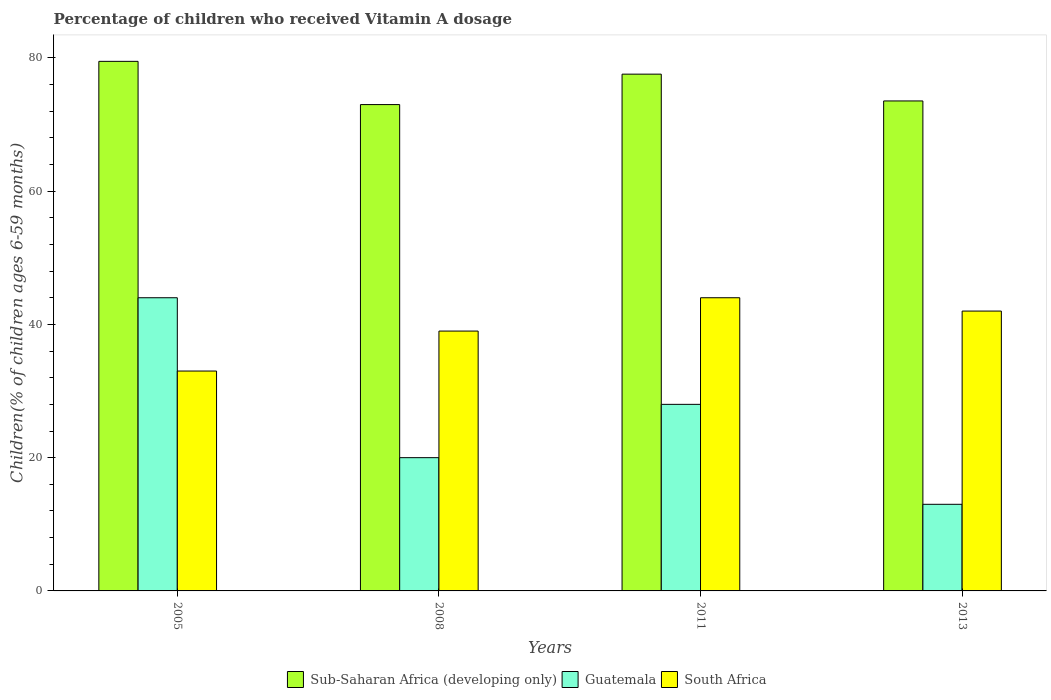How many groups of bars are there?
Your answer should be compact. 4. Are the number of bars per tick equal to the number of legend labels?
Provide a short and direct response. Yes. What is the label of the 4th group of bars from the left?
Offer a very short reply. 2013. In how many cases, is the number of bars for a given year not equal to the number of legend labels?
Offer a very short reply. 0. Across all years, what is the minimum percentage of children who received Vitamin A dosage in Guatemala?
Your response must be concise. 13. In which year was the percentage of children who received Vitamin A dosage in Guatemala minimum?
Ensure brevity in your answer.  2013. What is the total percentage of children who received Vitamin A dosage in Sub-Saharan Africa (developing only) in the graph?
Offer a terse response. 303.56. What is the difference between the percentage of children who received Vitamin A dosage in Sub-Saharan Africa (developing only) in 2008 and the percentage of children who received Vitamin A dosage in Guatemala in 2011?
Make the answer very short. 44.99. What is the average percentage of children who received Vitamin A dosage in Sub-Saharan Africa (developing only) per year?
Your response must be concise. 75.89. In the year 2008, what is the difference between the percentage of children who received Vitamin A dosage in South Africa and percentage of children who received Vitamin A dosage in Sub-Saharan Africa (developing only)?
Provide a short and direct response. -33.99. In how many years, is the percentage of children who received Vitamin A dosage in South Africa greater than 44 %?
Your response must be concise. 0. What is the ratio of the percentage of children who received Vitamin A dosage in Sub-Saharan Africa (developing only) in 2005 to that in 2011?
Keep it short and to the point. 1.02. Is the percentage of children who received Vitamin A dosage in Sub-Saharan Africa (developing only) in 2008 less than that in 2011?
Your answer should be compact. Yes. What is the difference between the highest and the second highest percentage of children who received Vitamin A dosage in Sub-Saharan Africa (developing only)?
Give a very brief answer. 1.92. What is the difference between the highest and the lowest percentage of children who received Vitamin A dosage in Sub-Saharan Africa (developing only)?
Ensure brevity in your answer.  6.49. What does the 2nd bar from the left in 2005 represents?
Offer a terse response. Guatemala. What does the 2nd bar from the right in 2005 represents?
Offer a terse response. Guatemala. Does the graph contain grids?
Give a very brief answer. No. How many legend labels are there?
Ensure brevity in your answer.  3. What is the title of the graph?
Ensure brevity in your answer.  Percentage of children who received Vitamin A dosage. Does "Mauritius" appear as one of the legend labels in the graph?
Offer a very short reply. No. What is the label or title of the X-axis?
Your answer should be very brief. Years. What is the label or title of the Y-axis?
Your response must be concise. Children(% of children ages 6-59 months). What is the Children(% of children ages 6-59 months) of Sub-Saharan Africa (developing only) in 2005?
Offer a very short reply. 79.48. What is the Children(% of children ages 6-59 months) of Guatemala in 2005?
Provide a succinct answer. 44. What is the Children(% of children ages 6-59 months) in South Africa in 2005?
Offer a terse response. 33. What is the Children(% of children ages 6-59 months) in Sub-Saharan Africa (developing only) in 2008?
Provide a succinct answer. 72.99. What is the Children(% of children ages 6-59 months) in Guatemala in 2008?
Provide a succinct answer. 20. What is the Children(% of children ages 6-59 months) of Sub-Saharan Africa (developing only) in 2011?
Make the answer very short. 77.56. What is the Children(% of children ages 6-59 months) in Guatemala in 2011?
Your answer should be very brief. 28. What is the Children(% of children ages 6-59 months) of Sub-Saharan Africa (developing only) in 2013?
Your answer should be very brief. 73.54. What is the Children(% of children ages 6-59 months) in Guatemala in 2013?
Your answer should be compact. 13. What is the Children(% of children ages 6-59 months) in South Africa in 2013?
Your response must be concise. 42. Across all years, what is the maximum Children(% of children ages 6-59 months) in Sub-Saharan Africa (developing only)?
Keep it short and to the point. 79.48. Across all years, what is the maximum Children(% of children ages 6-59 months) in Guatemala?
Provide a succinct answer. 44. Across all years, what is the maximum Children(% of children ages 6-59 months) of South Africa?
Offer a terse response. 44. Across all years, what is the minimum Children(% of children ages 6-59 months) of Sub-Saharan Africa (developing only)?
Make the answer very short. 72.99. Across all years, what is the minimum Children(% of children ages 6-59 months) of South Africa?
Your answer should be compact. 33. What is the total Children(% of children ages 6-59 months) of Sub-Saharan Africa (developing only) in the graph?
Keep it short and to the point. 303.56. What is the total Children(% of children ages 6-59 months) in Guatemala in the graph?
Your response must be concise. 105. What is the total Children(% of children ages 6-59 months) of South Africa in the graph?
Your answer should be compact. 158. What is the difference between the Children(% of children ages 6-59 months) in Sub-Saharan Africa (developing only) in 2005 and that in 2008?
Offer a terse response. 6.49. What is the difference between the Children(% of children ages 6-59 months) in South Africa in 2005 and that in 2008?
Offer a terse response. -6. What is the difference between the Children(% of children ages 6-59 months) of Sub-Saharan Africa (developing only) in 2005 and that in 2011?
Keep it short and to the point. 1.92. What is the difference between the Children(% of children ages 6-59 months) of Sub-Saharan Africa (developing only) in 2005 and that in 2013?
Your answer should be compact. 5.94. What is the difference between the Children(% of children ages 6-59 months) in South Africa in 2005 and that in 2013?
Give a very brief answer. -9. What is the difference between the Children(% of children ages 6-59 months) of Sub-Saharan Africa (developing only) in 2008 and that in 2011?
Ensure brevity in your answer.  -4.57. What is the difference between the Children(% of children ages 6-59 months) of Guatemala in 2008 and that in 2011?
Provide a short and direct response. -8. What is the difference between the Children(% of children ages 6-59 months) of Sub-Saharan Africa (developing only) in 2008 and that in 2013?
Give a very brief answer. -0.55. What is the difference between the Children(% of children ages 6-59 months) in Sub-Saharan Africa (developing only) in 2011 and that in 2013?
Make the answer very short. 4.02. What is the difference between the Children(% of children ages 6-59 months) in Sub-Saharan Africa (developing only) in 2005 and the Children(% of children ages 6-59 months) in Guatemala in 2008?
Provide a succinct answer. 59.48. What is the difference between the Children(% of children ages 6-59 months) of Sub-Saharan Africa (developing only) in 2005 and the Children(% of children ages 6-59 months) of South Africa in 2008?
Provide a short and direct response. 40.48. What is the difference between the Children(% of children ages 6-59 months) in Guatemala in 2005 and the Children(% of children ages 6-59 months) in South Africa in 2008?
Your response must be concise. 5. What is the difference between the Children(% of children ages 6-59 months) in Sub-Saharan Africa (developing only) in 2005 and the Children(% of children ages 6-59 months) in Guatemala in 2011?
Your response must be concise. 51.48. What is the difference between the Children(% of children ages 6-59 months) of Sub-Saharan Africa (developing only) in 2005 and the Children(% of children ages 6-59 months) of South Africa in 2011?
Your answer should be compact. 35.48. What is the difference between the Children(% of children ages 6-59 months) of Sub-Saharan Africa (developing only) in 2005 and the Children(% of children ages 6-59 months) of Guatemala in 2013?
Provide a short and direct response. 66.48. What is the difference between the Children(% of children ages 6-59 months) in Sub-Saharan Africa (developing only) in 2005 and the Children(% of children ages 6-59 months) in South Africa in 2013?
Your answer should be very brief. 37.48. What is the difference between the Children(% of children ages 6-59 months) of Guatemala in 2005 and the Children(% of children ages 6-59 months) of South Africa in 2013?
Offer a terse response. 2. What is the difference between the Children(% of children ages 6-59 months) in Sub-Saharan Africa (developing only) in 2008 and the Children(% of children ages 6-59 months) in Guatemala in 2011?
Your answer should be compact. 44.99. What is the difference between the Children(% of children ages 6-59 months) of Sub-Saharan Africa (developing only) in 2008 and the Children(% of children ages 6-59 months) of South Africa in 2011?
Provide a succinct answer. 28.99. What is the difference between the Children(% of children ages 6-59 months) of Guatemala in 2008 and the Children(% of children ages 6-59 months) of South Africa in 2011?
Your answer should be compact. -24. What is the difference between the Children(% of children ages 6-59 months) in Sub-Saharan Africa (developing only) in 2008 and the Children(% of children ages 6-59 months) in Guatemala in 2013?
Your answer should be very brief. 59.99. What is the difference between the Children(% of children ages 6-59 months) of Sub-Saharan Africa (developing only) in 2008 and the Children(% of children ages 6-59 months) of South Africa in 2013?
Offer a terse response. 30.99. What is the difference between the Children(% of children ages 6-59 months) in Guatemala in 2008 and the Children(% of children ages 6-59 months) in South Africa in 2013?
Offer a terse response. -22. What is the difference between the Children(% of children ages 6-59 months) of Sub-Saharan Africa (developing only) in 2011 and the Children(% of children ages 6-59 months) of Guatemala in 2013?
Ensure brevity in your answer.  64.56. What is the difference between the Children(% of children ages 6-59 months) of Sub-Saharan Africa (developing only) in 2011 and the Children(% of children ages 6-59 months) of South Africa in 2013?
Provide a succinct answer. 35.56. What is the average Children(% of children ages 6-59 months) in Sub-Saharan Africa (developing only) per year?
Your response must be concise. 75.89. What is the average Children(% of children ages 6-59 months) of Guatemala per year?
Offer a terse response. 26.25. What is the average Children(% of children ages 6-59 months) in South Africa per year?
Offer a very short reply. 39.5. In the year 2005, what is the difference between the Children(% of children ages 6-59 months) of Sub-Saharan Africa (developing only) and Children(% of children ages 6-59 months) of Guatemala?
Provide a succinct answer. 35.48. In the year 2005, what is the difference between the Children(% of children ages 6-59 months) of Sub-Saharan Africa (developing only) and Children(% of children ages 6-59 months) of South Africa?
Make the answer very short. 46.48. In the year 2005, what is the difference between the Children(% of children ages 6-59 months) of Guatemala and Children(% of children ages 6-59 months) of South Africa?
Your answer should be compact. 11. In the year 2008, what is the difference between the Children(% of children ages 6-59 months) in Sub-Saharan Africa (developing only) and Children(% of children ages 6-59 months) in Guatemala?
Keep it short and to the point. 52.99. In the year 2008, what is the difference between the Children(% of children ages 6-59 months) in Sub-Saharan Africa (developing only) and Children(% of children ages 6-59 months) in South Africa?
Ensure brevity in your answer.  33.99. In the year 2011, what is the difference between the Children(% of children ages 6-59 months) of Sub-Saharan Africa (developing only) and Children(% of children ages 6-59 months) of Guatemala?
Your response must be concise. 49.56. In the year 2011, what is the difference between the Children(% of children ages 6-59 months) in Sub-Saharan Africa (developing only) and Children(% of children ages 6-59 months) in South Africa?
Provide a succinct answer. 33.56. In the year 2011, what is the difference between the Children(% of children ages 6-59 months) of Guatemala and Children(% of children ages 6-59 months) of South Africa?
Provide a succinct answer. -16. In the year 2013, what is the difference between the Children(% of children ages 6-59 months) in Sub-Saharan Africa (developing only) and Children(% of children ages 6-59 months) in Guatemala?
Provide a succinct answer. 60.54. In the year 2013, what is the difference between the Children(% of children ages 6-59 months) of Sub-Saharan Africa (developing only) and Children(% of children ages 6-59 months) of South Africa?
Provide a short and direct response. 31.54. What is the ratio of the Children(% of children ages 6-59 months) of Sub-Saharan Africa (developing only) in 2005 to that in 2008?
Your answer should be compact. 1.09. What is the ratio of the Children(% of children ages 6-59 months) in South Africa in 2005 to that in 2008?
Your answer should be compact. 0.85. What is the ratio of the Children(% of children ages 6-59 months) in Sub-Saharan Africa (developing only) in 2005 to that in 2011?
Offer a terse response. 1.02. What is the ratio of the Children(% of children ages 6-59 months) of Guatemala in 2005 to that in 2011?
Give a very brief answer. 1.57. What is the ratio of the Children(% of children ages 6-59 months) of Sub-Saharan Africa (developing only) in 2005 to that in 2013?
Your response must be concise. 1.08. What is the ratio of the Children(% of children ages 6-59 months) in Guatemala in 2005 to that in 2013?
Your answer should be compact. 3.38. What is the ratio of the Children(% of children ages 6-59 months) of South Africa in 2005 to that in 2013?
Ensure brevity in your answer.  0.79. What is the ratio of the Children(% of children ages 6-59 months) of Sub-Saharan Africa (developing only) in 2008 to that in 2011?
Offer a terse response. 0.94. What is the ratio of the Children(% of children ages 6-59 months) of South Africa in 2008 to that in 2011?
Offer a terse response. 0.89. What is the ratio of the Children(% of children ages 6-59 months) of Guatemala in 2008 to that in 2013?
Keep it short and to the point. 1.54. What is the ratio of the Children(% of children ages 6-59 months) of South Africa in 2008 to that in 2013?
Your answer should be very brief. 0.93. What is the ratio of the Children(% of children ages 6-59 months) in Sub-Saharan Africa (developing only) in 2011 to that in 2013?
Ensure brevity in your answer.  1.05. What is the ratio of the Children(% of children ages 6-59 months) in Guatemala in 2011 to that in 2013?
Make the answer very short. 2.15. What is the ratio of the Children(% of children ages 6-59 months) in South Africa in 2011 to that in 2013?
Give a very brief answer. 1.05. What is the difference between the highest and the second highest Children(% of children ages 6-59 months) in Sub-Saharan Africa (developing only)?
Offer a very short reply. 1.92. What is the difference between the highest and the second highest Children(% of children ages 6-59 months) of Guatemala?
Offer a very short reply. 16. What is the difference between the highest and the second highest Children(% of children ages 6-59 months) in South Africa?
Offer a very short reply. 2. What is the difference between the highest and the lowest Children(% of children ages 6-59 months) of Sub-Saharan Africa (developing only)?
Your answer should be compact. 6.49. What is the difference between the highest and the lowest Children(% of children ages 6-59 months) of Guatemala?
Offer a terse response. 31. 